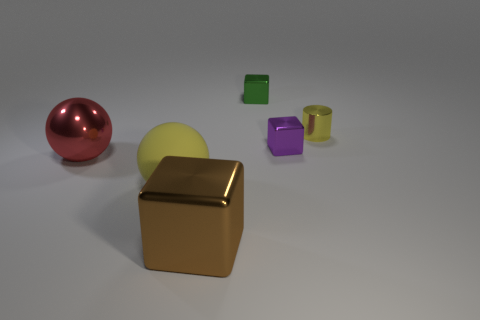There is a big brown object that is made of the same material as the green cube; what shape is it?
Give a very brief answer. Cube. The rubber thing that is the same color as the tiny metallic cylinder is what shape?
Your answer should be very brief. Sphere. Are there any small cylinders of the same color as the rubber thing?
Your response must be concise. Yes. Do the brown object and the small green object right of the rubber thing have the same shape?
Keep it short and to the point. Yes. What number of other objects are the same material as the tiny yellow cylinder?
Your response must be concise. 4. Are there any blocks right of the green metallic object?
Ensure brevity in your answer.  Yes. Does the rubber ball have the same size as the metal cube in front of the red metal thing?
Your answer should be very brief. Yes. What is the color of the metallic object in front of the big metallic thing to the left of the large yellow ball?
Provide a succinct answer. Brown. Do the cylinder and the matte sphere have the same size?
Your answer should be compact. No. What color is the metallic thing that is in front of the tiny purple object and behind the large metallic cube?
Make the answer very short. Red. 